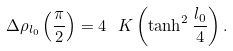Convert formula to latex. <formula><loc_0><loc_0><loc_500><loc_500>\Delta \rho _ { l _ { 0 } } \left ( \frac { \pi } { 2 } \right ) = 4 \ K \left ( \tanh ^ { 2 } \frac { l _ { 0 } } { 4 } \right ) .</formula> 